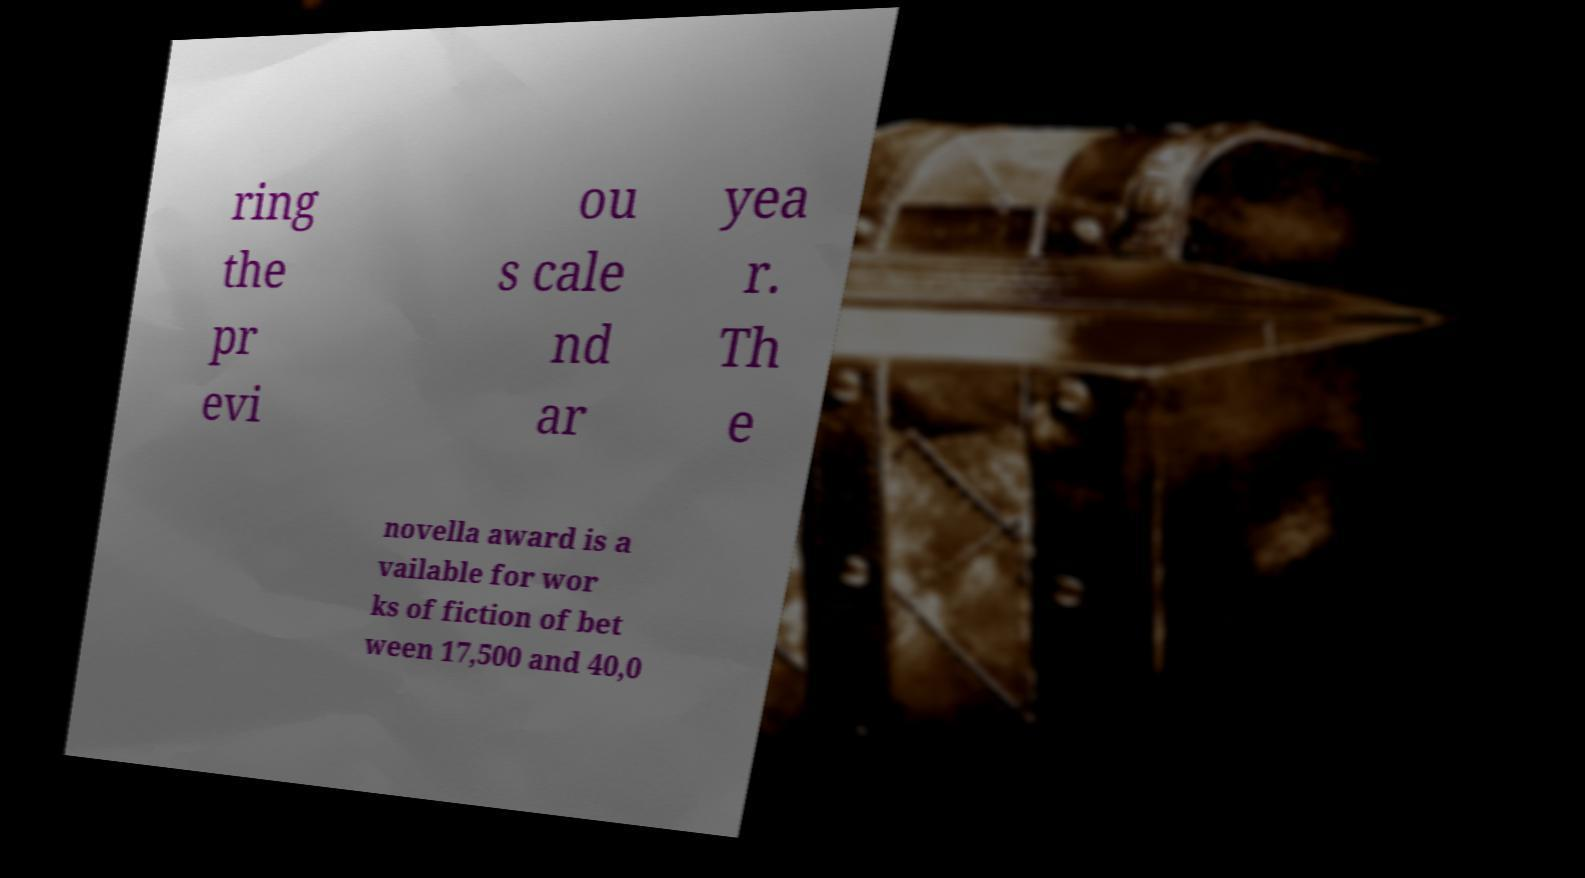Can you accurately transcribe the text from the provided image for me? ring the pr evi ou s cale nd ar yea r. Th e novella award is a vailable for wor ks of fiction of bet ween 17,500 and 40,0 